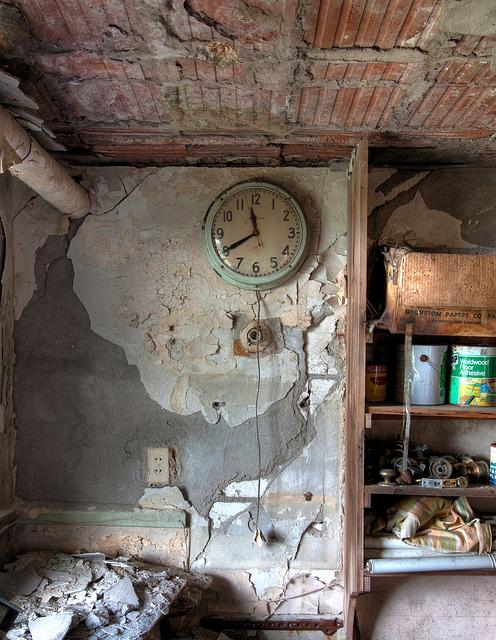Does this room need to be renovated?
Answer briefly. Yes. Has the wall been freshly painted?
Be succinct. No. What time is shown on the clock?
Keep it brief. 11:40. 